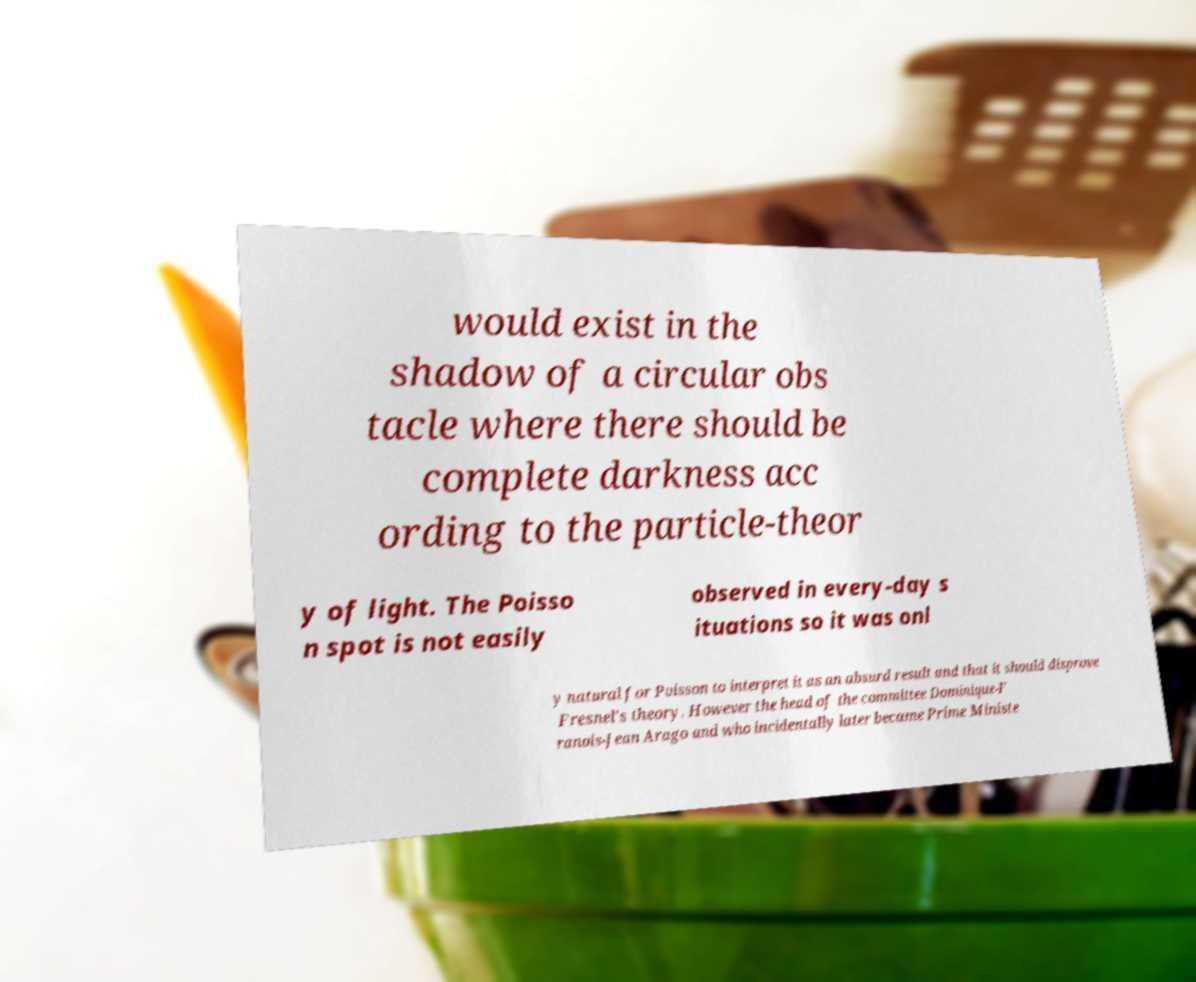Can you read and provide the text displayed in the image?This photo seems to have some interesting text. Can you extract and type it out for me? would exist in the shadow of a circular obs tacle where there should be complete darkness acc ording to the particle-theor y of light. The Poisso n spot is not easily observed in every-day s ituations so it was onl y natural for Poisson to interpret it as an absurd result and that it should disprove Fresnel's theory. However the head of the committee Dominique-F ranois-Jean Arago and who incidentally later became Prime Ministe 